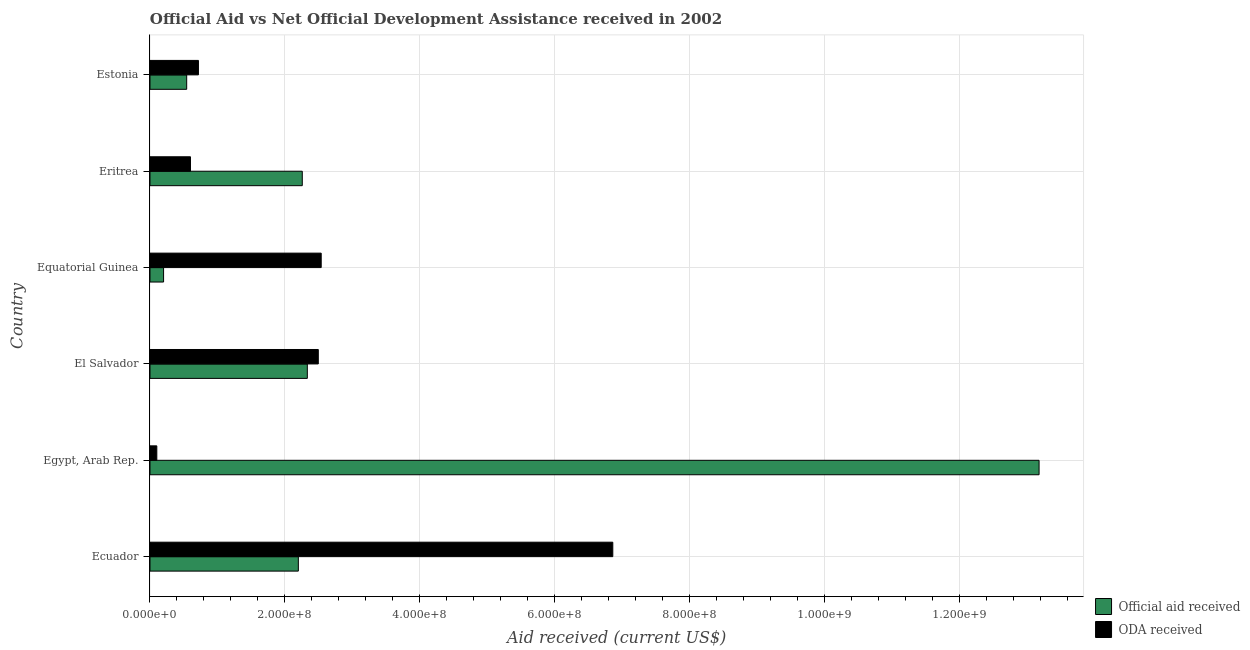How many groups of bars are there?
Make the answer very short. 6. Are the number of bars per tick equal to the number of legend labels?
Ensure brevity in your answer.  Yes. Are the number of bars on each tick of the Y-axis equal?
Make the answer very short. Yes. What is the label of the 3rd group of bars from the top?
Offer a very short reply. Equatorial Guinea. In how many cases, is the number of bars for a given country not equal to the number of legend labels?
Ensure brevity in your answer.  0. What is the oda received in Eritrea?
Keep it short and to the point. 6.00e+07. Across all countries, what is the maximum oda received?
Keep it short and to the point. 6.86e+08. Across all countries, what is the minimum oda received?
Your answer should be compact. 1.01e+07. In which country was the official aid received maximum?
Your answer should be very brief. Egypt, Arab Rep. In which country was the oda received minimum?
Offer a terse response. Egypt, Arab Rep. What is the total official aid received in the graph?
Ensure brevity in your answer.  2.07e+09. What is the difference between the official aid received in Egypt, Arab Rep. and that in Estonia?
Offer a very short reply. 1.26e+09. What is the difference between the official aid received in Estonia and the oda received in Equatorial Guinea?
Provide a short and direct response. -1.99e+08. What is the average official aid received per country?
Offer a very short reply. 3.45e+08. What is the difference between the oda received and official aid received in Eritrea?
Ensure brevity in your answer.  -1.66e+08. What is the ratio of the official aid received in Ecuador to that in Eritrea?
Give a very brief answer. 0.97. Is the difference between the oda received in Ecuador and Equatorial Guinea greater than the difference between the official aid received in Ecuador and Equatorial Guinea?
Make the answer very short. Yes. What is the difference between the highest and the second highest official aid received?
Your answer should be compact. 1.08e+09. What is the difference between the highest and the lowest official aid received?
Keep it short and to the point. 1.30e+09. In how many countries, is the oda received greater than the average oda received taken over all countries?
Your response must be concise. 3. Is the sum of the official aid received in Ecuador and Eritrea greater than the maximum oda received across all countries?
Your response must be concise. No. What does the 1st bar from the top in Eritrea represents?
Keep it short and to the point. ODA received. What does the 1st bar from the bottom in El Salvador represents?
Make the answer very short. Official aid received. Are all the bars in the graph horizontal?
Keep it short and to the point. Yes. Are the values on the major ticks of X-axis written in scientific E-notation?
Give a very brief answer. Yes. Does the graph contain grids?
Offer a terse response. Yes. Where does the legend appear in the graph?
Your answer should be very brief. Bottom right. What is the title of the graph?
Make the answer very short. Official Aid vs Net Official Development Assistance received in 2002 . What is the label or title of the X-axis?
Your answer should be very brief. Aid received (current US$). What is the label or title of the Y-axis?
Ensure brevity in your answer.  Country. What is the Aid received (current US$) in Official aid received in Ecuador?
Offer a very short reply. 2.20e+08. What is the Aid received (current US$) in ODA received in Ecuador?
Offer a very short reply. 6.86e+08. What is the Aid received (current US$) in Official aid received in Egypt, Arab Rep.?
Give a very brief answer. 1.32e+09. What is the Aid received (current US$) in ODA received in Egypt, Arab Rep.?
Your answer should be compact. 1.01e+07. What is the Aid received (current US$) of Official aid received in El Salvador?
Your answer should be very brief. 2.33e+08. What is the Aid received (current US$) in ODA received in El Salvador?
Your answer should be compact. 2.50e+08. What is the Aid received (current US$) of Official aid received in Equatorial Guinea?
Your response must be concise. 2.02e+07. What is the Aid received (current US$) of ODA received in Equatorial Guinea?
Keep it short and to the point. 2.54e+08. What is the Aid received (current US$) in Official aid received in Eritrea?
Give a very brief answer. 2.26e+08. What is the Aid received (current US$) of ODA received in Eritrea?
Offer a terse response. 6.00e+07. What is the Aid received (current US$) in Official aid received in Estonia?
Your response must be concise. 5.44e+07. What is the Aid received (current US$) of ODA received in Estonia?
Offer a very short reply. 7.18e+07. Across all countries, what is the maximum Aid received (current US$) in Official aid received?
Offer a terse response. 1.32e+09. Across all countries, what is the maximum Aid received (current US$) in ODA received?
Ensure brevity in your answer.  6.86e+08. Across all countries, what is the minimum Aid received (current US$) in Official aid received?
Provide a succinct answer. 2.02e+07. Across all countries, what is the minimum Aid received (current US$) of ODA received?
Your answer should be very brief. 1.01e+07. What is the total Aid received (current US$) in Official aid received in the graph?
Keep it short and to the point. 2.07e+09. What is the total Aid received (current US$) in ODA received in the graph?
Your response must be concise. 1.33e+09. What is the difference between the Aid received (current US$) in Official aid received in Ecuador and that in Egypt, Arab Rep.?
Provide a short and direct response. -1.10e+09. What is the difference between the Aid received (current US$) in ODA received in Ecuador and that in Egypt, Arab Rep.?
Ensure brevity in your answer.  6.76e+08. What is the difference between the Aid received (current US$) in Official aid received in Ecuador and that in El Salvador?
Offer a very short reply. -1.33e+07. What is the difference between the Aid received (current US$) of ODA received in Ecuador and that in El Salvador?
Ensure brevity in your answer.  4.37e+08. What is the difference between the Aid received (current US$) in Official aid received in Ecuador and that in Equatorial Guinea?
Your response must be concise. 2.00e+08. What is the difference between the Aid received (current US$) in ODA received in Ecuador and that in Equatorial Guinea?
Make the answer very short. 4.32e+08. What is the difference between the Aid received (current US$) of Official aid received in Ecuador and that in Eritrea?
Your response must be concise. -5.82e+06. What is the difference between the Aid received (current US$) of ODA received in Ecuador and that in Eritrea?
Provide a succinct answer. 6.26e+08. What is the difference between the Aid received (current US$) of Official aid received in Ecuador and that in Estonia?
Provide a succinct answer. 1.66e+08. What is the difference between the Aid received (current US$) of ODA received in Ecuador and that in Estonia?
Give a very brief answer. 6.14e+08. What is the difference between the Aid received (current US$) in Official aid received in Egypt, Arab Rep. and that in El Salvador?
Your answer should be compact. 1.08e+09. What is the difference between the Aid received (current US$) of ODA received in Egypt, Arab Rep. and that in El Salvador?
Ensure brevity in your answer.  -2.39e+08. What is the difference between the Aid received (current US$) of Official aid received in Egypt, Arab Rep. and that in Equatorial Guinea?
Give a very brief answer. 1.30e+09. What is the difference between the Aid received (current US$) of ODA received in Egypt, Arab Rep. and that in Equatorial Guinea?
Make the answer very short. -2.44e+08. What is the difference between the Aid received (current US$) in Official aid received in Egypt, Arab Rep. and that in Eritrea?
Provide a succinct answer. 1.09e+09. What is the difference between the Aid received (current US$) of ODA received in Egypt, Arab Rep. and that in Eritrea?
Provide a succinct answer. -4.99e+07. What is the difference between the Aid received (current US$) in Official aid received in Egypt, Arab Rep. and that in Estonia?
Make the answer very short. 1.26e+09. What is the difference between the Aid received (current US$) in ODA received in Egypt, Arab Rep. and that in Estonia?
Ensure brevity in your answer.  -6.17e+07. What is the difference between the Aid received (current US$) of Official aid received in El Salvador and that in Equatorial Guinea?
Offer a terse response. 2.13e+08. What is the difference between the Aid received (current US$) of ODA received in El Salvador and that in Equatorial Guinea?
Provide a succinct answer. -4.31e+06. What is the difference between the Aid received (current US$) in Official aid received in El Salvador and that in Eritrea?
Make the answer very short. 7.50e+06. What is the difference between the Aid received (current US$) of ODA received in El Salvador and that in Eritrea?
Give a very brief answer. 1.90e+08. What is the difference between the Aid received (current US$) in Official aid received in El Salvador and that in Estonia?
Your answer should be very brief. 1.79e+08. What is the difference between the Aid received (current US$) in ODA received in El Salvador and that in Estonia?
Your answer should be very brief. 1.78e+08. What is the difference between the Aid received (current US$) in Official aid received in Equatorial Guinea and that in Eritrea?
Your answer should be compact. -2.06e+08. What is the difference between the Aid received (current US$) in ODA received in Equatorial Guinea and that in Eritrea?
Provide a succinct answer. 1.94e+08. What is the difference between the Aid received (current US$) in Official aid received in Equatorial Guinea and that in Estonia?
Offer a very short reply. -3.43e+07. What is the difference between the Aid received (current US$) of ODA received in Equatorial Guinea and that in Estonia?
Make the answer very short. 1.82e+08. What is the difference between the Aid received (current US$) of Official aid received in Eritrea and that in Estonia?
Ensure brevity in your answer.  1.71e+08. What is the difference between the Aid received (current US$) in ODA received in Eritrea and that in Estonia?
Your answer should be compact. -1.18e+07. What is the difference between the Aid received (current US$) of Official aid received in Ecuador and the Aid received (current US$) of ODA received in Egypt, Arab Rep.?
Your response must be concise. 2.10e+08. What is the difference between the Aid received (current US$) in Official aid received in Ecuador and the Aid received (current US$) in ODA received in El Salvador?
Provide a succinct answer. -2.96e+07. What is the difference between the Aid received (current US$) in Official aid received in Ecuador and the Aid received (current US$) in ODA received in Equatorial Guinea?
Your answer should be very brief. -3.39e+07. What is the difference between the Aid received (current US$) in Official aid received in Ecuador and the Aid received (current US$) in ODA received in Eritrea?
Your response must be concise. 1.60e+08. What is the difference between the Aid received (current US$) of Official aid received in Ecuador and the Aid received (current US$) of ODA received in Estonia?
Your answer should be very brief. 1.48e+08. What is the difference between the Aid received (current US$) in Official aid received in Egypt, Arab Rep. and the Aid received (current US$) in ODA received in El Salvador?
Make the answer very short. 1.07e+09. What is the difference between the Aid received (current US$) in Official aid received in Egypt, Arab Rep. and the Aid received (current US$) in ODA received in Equatorial Guinea?
Provide a short and direct response. 1.06e+09. What is the difference between the Aid received (current US$) of Official aid received in Egypt, Arab Rep. and the Aid received (current US$) of ODA received in Eritrea?
Make the answer very short. 1.26e+09. What is the difference between the Aid received (current US$) in Official aid received in Egypt, Arab Rep. and the Aid received (current US$) in ODA received in Estonia?
Keep it short and to the point. 1.25e+09. What is the difference between the Aid received (current US$) in Official aid received in El Salvador and the Aid received (current US$) in ODA received in Equatorial Guinea?
Your response must be concise. -2.06e+07. What is the difference between the Aid received (current US$) in Official aid received in El Salvador and the Aid received (current US$) in ODA received in Eritrea?
Your answer should be compact. 1.73e+08. What is the difference between the Aid received (current US$) in Official aid received in El Salvador and the Aid received (current US$) in ODA received in Estonia?
Offer a terse response. 1.61e+08. What is the difference between the Aid received (current US$) in Official aid received in Equatorial Guinea and the Aid received (current US$) in ODA received in Eritrea?
Offer a terse response. -3.99e+07. What is the difference between the Aid received (current US$) of Official aid received in Equatorial Guinea and the Aid received (current US$) of ODA received in Estonia?
Provide a succinct answer. -5.17e+07. What is the difference between the Aid received (current US$) in Official aid received in Eritrea and the Aid received (current US$) in ODA received in Estonia?
Ensure brevity in your answer.  1.54e+08. What is the average Aid received (current US$) of Official aid received per country?
Give a very brief answer. 3.45e+08. What is the average Aid received (current US$) of ODA received per country?
Offer a very short reply. 2.22e+08. What is the difference between the Aid received (current US$) of Official aid received and Aid received (current US$) of ODA received in Ecuador?
Make the answer very short. -4.66e+08. What is the difference between the Aid received (current US$) in Official aid received and Aid received (current US$) in ODA received in Egypt, Arab Rep.?
Give a very brief answer. 1.31e+09. What is the difference between the Aid received (current US$) in Official aid received and Aid received (current US$) in ODA received in El Salvador?
Provide a succinct answer. -1.63e+07. What is the difference between the Aid received (current US$) of Official aid received and Aid received (current US$) of ODA received in Equatorial Guinea?
Provide a short and direct response. -2.34e+08. What is the difference between the Aid received (current US$) of Official aid received and Aid received (current US$) of ODA received in Eritrea?
Provide a succinct answer. 1.66e+08. What is the difference between the Aid received (current US$) of Official aid received and Aid received (current US$) of ODA received in Estonia?
Your answer should be very brief. -1.74e+07. What is the ratio of the Aid received (current US$) of Official aid received in Ecuador to that in Egypt, Arab Rep.?
Your response must be concise. 0.17. What is the ratio of the Aid received (current US$) of ODA received in Ecuador to that in Egypt, Arab Rep.?
Your answer should be compact. 67.81. What is the ratio of the Aid received (current US$) in Official aid received in Ecuador to that in El Salvador?
Make the answer very short. 0.94. What is the ratio of the Aid received (current US$) in ODA received in Ecuador to that in El Salvador?
Make the answer very short. 2.75. What is the ratio of the Aid received (current US$) of Official aid received in Ecuador to that in Equatorial Guinea?
Ensure brevity in your answer.  10.92. What is the ratio of the Aid received (current US$) in ODA received in Ecuador to that in Equatorial Guinea?
Keep it short and to the point. 2.7. What is the ratio of the Aid received (current US$) of Official aid received in Ecuador to that in Eritrea?
Your response must be concise. 0.97. What is the ratio of the Aid received (current US$) in ODA received in Ecuador to that in Eritrea?
Ensure brevity in your answer.  11.43. What is the ratio of the Aid received (current US$) in Official aid received in Ecuador to that in Estonia?
Your answer should be very brief. 4.04. What is the ratio of the Aid received (current US$) in ODA received in Ecuador to that in Estonia?
Offer a very short reply. 9.55. What is the ratio of the Aid received (current US$) in Official aid received in Egypt, Arab Rep. to that in El Salvador?
Offer a very short reply. 5.65. What is the ratio of the Aid received (current US$) of ODA received in Egypt, Arab Rep. to that in El Salvador?
Your response must be concise. 0.04. What is the ratio of the Aid received (current US$) in Official aid received in Egypt, Arab Rep. to that in Equatorial Guinea?
Provide a short and direct response. 65.42. What is the ratio of the Aid received (current US$) in ODA received in Egypt, Arab Rep. to that in Equatorial Guinea?
Your answer should be very brief. 0.04. What is the ratio of the Aid received (current US$) in Official aid received in Egypt, Arab Rep. to that in Eritrea?
Make the answer very short. 5.84. What is the ratio of the Aid received (current US$) in ODA received in Egypt, Arab Rep. to that in Eritrea?
Offer a very short reply. 0.17. What is the ratio of the Aid received (current US$) of Official aid received in Egypt, Arab Rep. to that in Estonia?
Offer a terse response. 24.23. What is the ratio of the Aid received (current US$) in ODA received in Egypt, Arab Rep. to that in Estonia?
Provide a short and direct response. 0.14. What is the ratio of the Aid received (current US$) in Official aid received in El Salvador to that in Equatorial Guinea?
Keep it short and to the point. 11.58. What is the ratio of the Aid received (current US$) in ODA received in El Salvador to that in Equatorial Guinea?
Offer a terse response. 0.98. What is the ratio of the Aid received (current US$) in Official aid received in El Salvador to that in Eritrea?
Offer a very short reply. 1.03. What is the ratio of the Aid received (current US$) in ODA received in El Salvador to that in Eritrea?
Provide a short and direct response. 4.16. What is the ratio of the Aid received (current US$) of Official aid received in El Salvador to that in Estonia?
Offer a terse response. 4.29. What is the ratio of the Aid received (current US$) in ODA received in El Salvador to that in Estonia?
Ensure brevity in your answer.  3.47. What is the ratio of the Aid received (current US$) in Official aid received in Equatorial Guinea to that in Eritrea?
Make the answer very short. 0.09. What is the ratio of the Aid received (current US$) of ODA received in Equatorial Guinea to that in Eritrea?
Your answer should be very brief. 4.23. What is the ratio of the Aid received (current US$) of Official aid received in Equatorial Guinea to that in Estonia?
Your answer should be very brief. 0.37. What is the ratio of the Aid received (current US$) in ODA received in Equatorial Guinea to that in Estonia?
Keep it short and to the point. 3.53. What is the ratio of the Aid received (current US$) in Official aid received in Eritrea to that in Estonia?
Provide a succinct answer. 4.15. What is the ratio of the Aid received (current US$) in ODA received in Eritrea to that in Estonia?
Ensure brevity in your answer.  0.84. What is the difference between the highest and the second highest Aid received (current US$) of Official aid received?
Your answer should be compact. 1.08e+09. What is the difference between the highest and the second highest Aid received (current US$) of ODA received?
Your answer should be very brief. 4.32e+08. What is the difference between the highest and the lowest Aid received (current US$) in Official aid received?
Provide a succinct answer. 1.30e+09. What is the difference between the highest and the lowest Aid received (current US$) in ODA received?
Keep it short and to the point. 6.76e+08. 